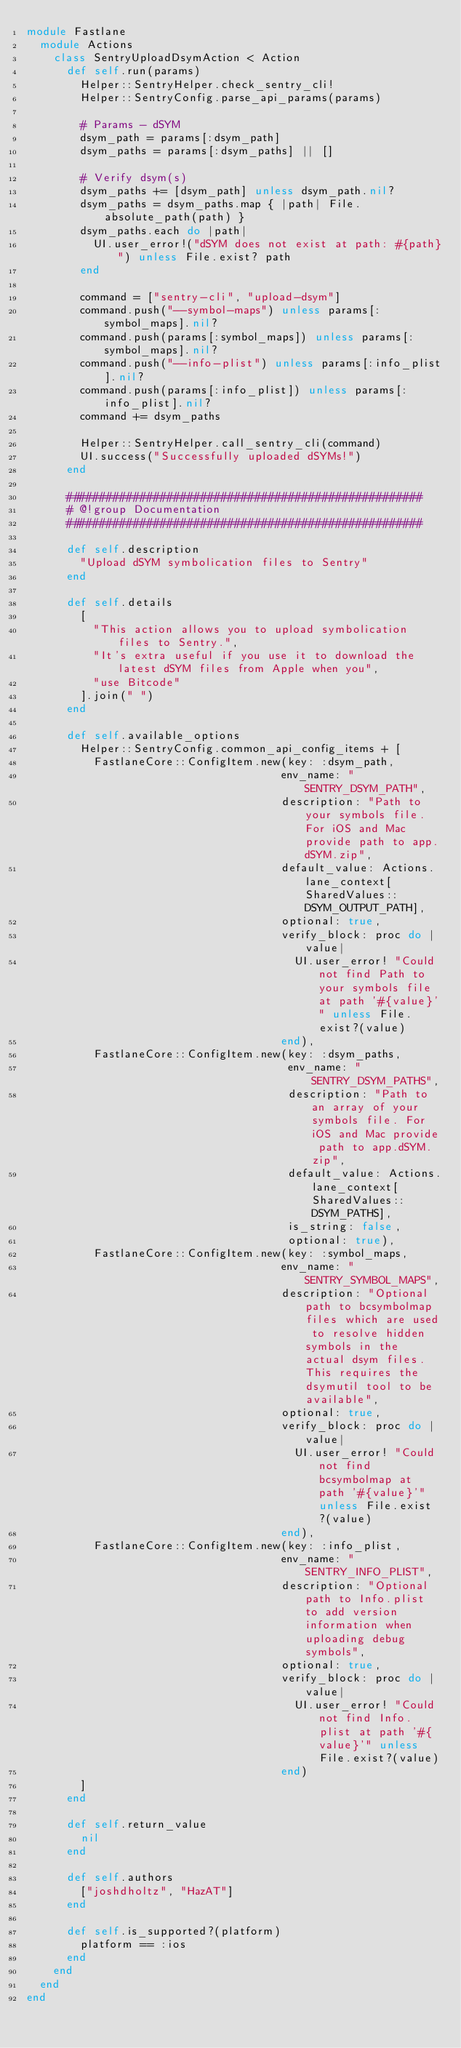<code> <loc_0><loc_0><loc_500><loc_500><_Ruby_>module Fastlane
  module Actions
    class SentryUploadDsymAction < Action
      def self.run(params)
        Helper::SentryHelper.check_sentry_cli!
        Helper::SentryConfig.parse_api_params(params)

        # Params - dSYM
        dsym_path = params[:dsym_path]
        dsym_paths = params[:dsym_paths] || []

        # Verify dsym(s)
        dsym_paths += [dsym_path] unless dsym_path.nil?
        dsym_paths = dsym_paths.map { |path| File.absolute_path(path) }
        dsym_paths.each do |path|
          UI.user_error!("dSYM does not exist at path: #{path}") unless File.exist? path
        end

        command = ["sentry-cli", "upload-dsym"]
        command.push("--symbol-maps") unless params[:symbol_maps].nil?
        command.push(params[:symbol_maps]) unless params[:symbol_maps].nil?
        command.push("--info-plist") unless params[:info_plist].nil?
        command.push(params[:info_plist]) unless params[:info_plist].nil?
        command += dsym_paths

        Helper::SentryHelper.call_sentry_cli(command)
        UI.success("Successfully uploaded dSYMs!")
      end

      #####################################################
      # @!group Documentation
      #####################################################

      def self.description
        "Upload dSYM symbolication files to Sentry"
      end

      def self.details
        [
          "This action allows you to upload symbolication files to Sentry.",
          "It's extra useful if you use it to download the latest dSYM files from Apple when you",
          "use Bitcode"
        ].join(" ")
      end

      def self.available_options
        Helper::SentryConfig.common_api_config_items + [
          FastlaneCore::ConfigItem.new(key: :dsym_path,
                                      env_name: "SENTRY_DSYM_PATH",
                                      description: "Path to your symbols file. For iOS and Mac provide path to app.dSYM.zip",
                                      default_value: Actions.lane_context[SharedValues::DSYM_OUTPUT_PATH],
                                      optional: true,
                                      verify_block: proc do |value|
                                        UI.user_error! "Could not find Path to your symbols file at path '#{value}'" unless File.exist?(value)
                                      end),
          FastlaneCore::ConfigItem.new(key: :dsym_paths,
                                       env_name: "SENTRY_DSYM_PATHS",
                                       description: "Path to an array of your symbols file. For iOS and Mac provide path to app.dSYM.zip",
                                       default_value: Actions.lane_context[SharedValues::DSYM_PATHS],
                                       is_string: false,
                                       optional: true),
          FastlaneCore::ConfigItem.new(key: :symbol_maps,
                                      env_name: "SENTRY_SYMBOL_MAPS",
                                      description: "Optional path to bcsymbolmap files which are used to resolve hidden symbols in the actual dsym files. This requires the dsymutil tool to be available",
                                      optional: true,
                                      verify_block: proc do |value|
                                        UI.user_error! "Could not find bcsymbolmap at path '#{value}'" unless File.exist?(value)
                                      end),
          FastlaneCore::ConfigItem.new(key: :info_plist,
                                      env_name: "SENTRY_INFO_PLIST",
                                      description: "Optional path to Info.plist to add version information when uploading debug symbols",
                                      optional: true,
                                      verify_block: proc do |value|
                                        UI.user_error! "Could not find Info.plist at path '#{value}'" unless File.exist?(value)
                                      end)
        ]
      end

      def self.return_value
        nil
      end

      def self.authors
        ["joshdholtz", "HazAT"]
      end

      def self.is_supported?(platform)
        platform == :ios
      end
    end
  end
end
</code> 